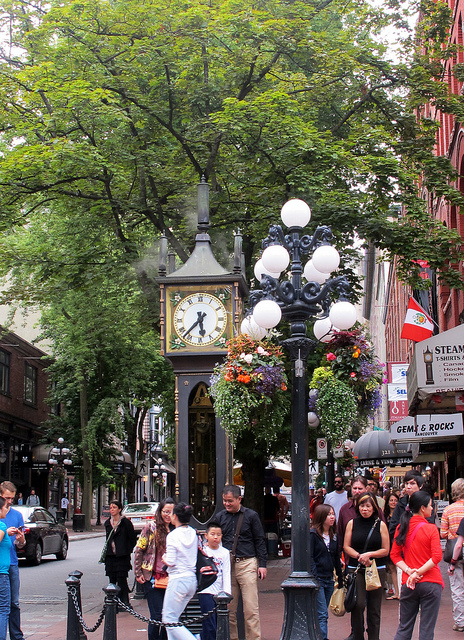Identify the text displayed in this image. STEAN T-SHIRTS Coop Hook f SCL &amp; ROCKS GEMS 